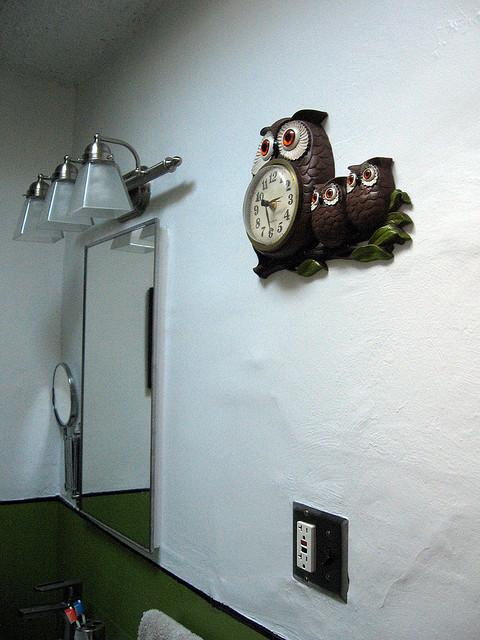What color is the bottom half of the wall?
Be succinct. Green. What room in the house is in this photo?
Concise answer only. Bathroom. What type of animals are on the clock?
Quick response, please. Owls. 